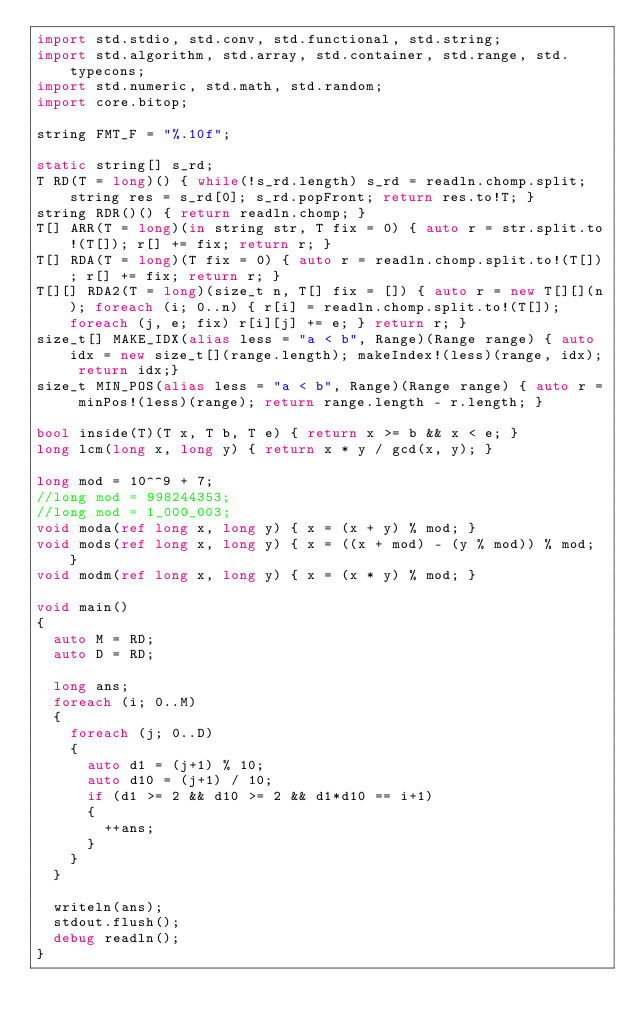<code> <loc_0><loc_0><loc_500><loc_500><_D_>import std.stdio, std.conv, std.functional, std.string;
import std.algorithm, std.array, std.container, std.range, std.typecons;
import std.numeric, std.math, std.random;
import core.bitop;

string FMT_F = "%.10f";

static string[] s_rd;
T RD(T = long)() { while(!s_rd.length) s_rd = readln.chomp.split; string res = s_rd[0]; s_rd.popFront; return res.to!T; }
string RDR()() { return readln.chomp; }
T[] ARR(T = long)(in string str, T fix = 0) { auto r = str.split.to!(T[]); r[] += fix; return r; }
T[] RDA(T = long)(T fix = 0) { auto r = readln.chomp.split.to!(T[]); r[] += fix; return r; }
T[][] RDA2(T = long)(size_t n, T[] fix = []) { auto r = new T[][](n); foreach (i; 0..n) { r[i] = readln.chomp.split.to!(T[]); foreach (j, e; fix) r[i][j] += e; } return r; }
size_t[] MAKE_IDX(alias less = "a < b", Range)(Range range) { auto idx = new size_t[](range.length); makeIndex!(less)(range, idx); return idx;}
size_t MIN_POS(alias less = "a < b", Range)(Range range) { auto r = minPos!(less)(range); return range.length - r.length; }

bool inside(T)(T x, T b, T e) { return x >= b && x < e; }
long lcm(long x, long y) { return x * y / gcd(x, y); }

long mod = 10^^9 + 7;
//long mod = 998244353;
//long mod = 1_000_003;
void moda(ref long x, long y) { x = (x + y) % mod; }
void mods(ref long x, long y) { x = ((x + mod) - (y % mod)) % mod; }
void modm(ref long x, long y) { x = (x * y) % mod; }

void main()
{
	auto M = RD;
	auto D = RD;

	long ans;
	foreach (i; 0..M)
	{
		foreach (j; 0..D)
		{
			auto d1 = (j+1) % 10;
			auto d10 = (j+1) / 10;
			if (d1 >= 2 && d10 >= 2 && d1*d10 == i+1)
			{
				++ans;
			}
		}
	}

	writeln(ans);
	stdout.flush();
	debug readln();
}</code> 